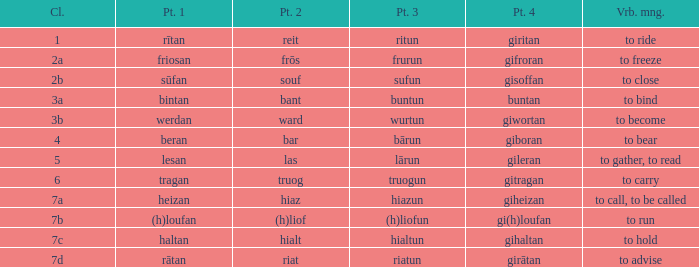What is the part 4 of the word with the part 1 "heizan"? Giheizan. 